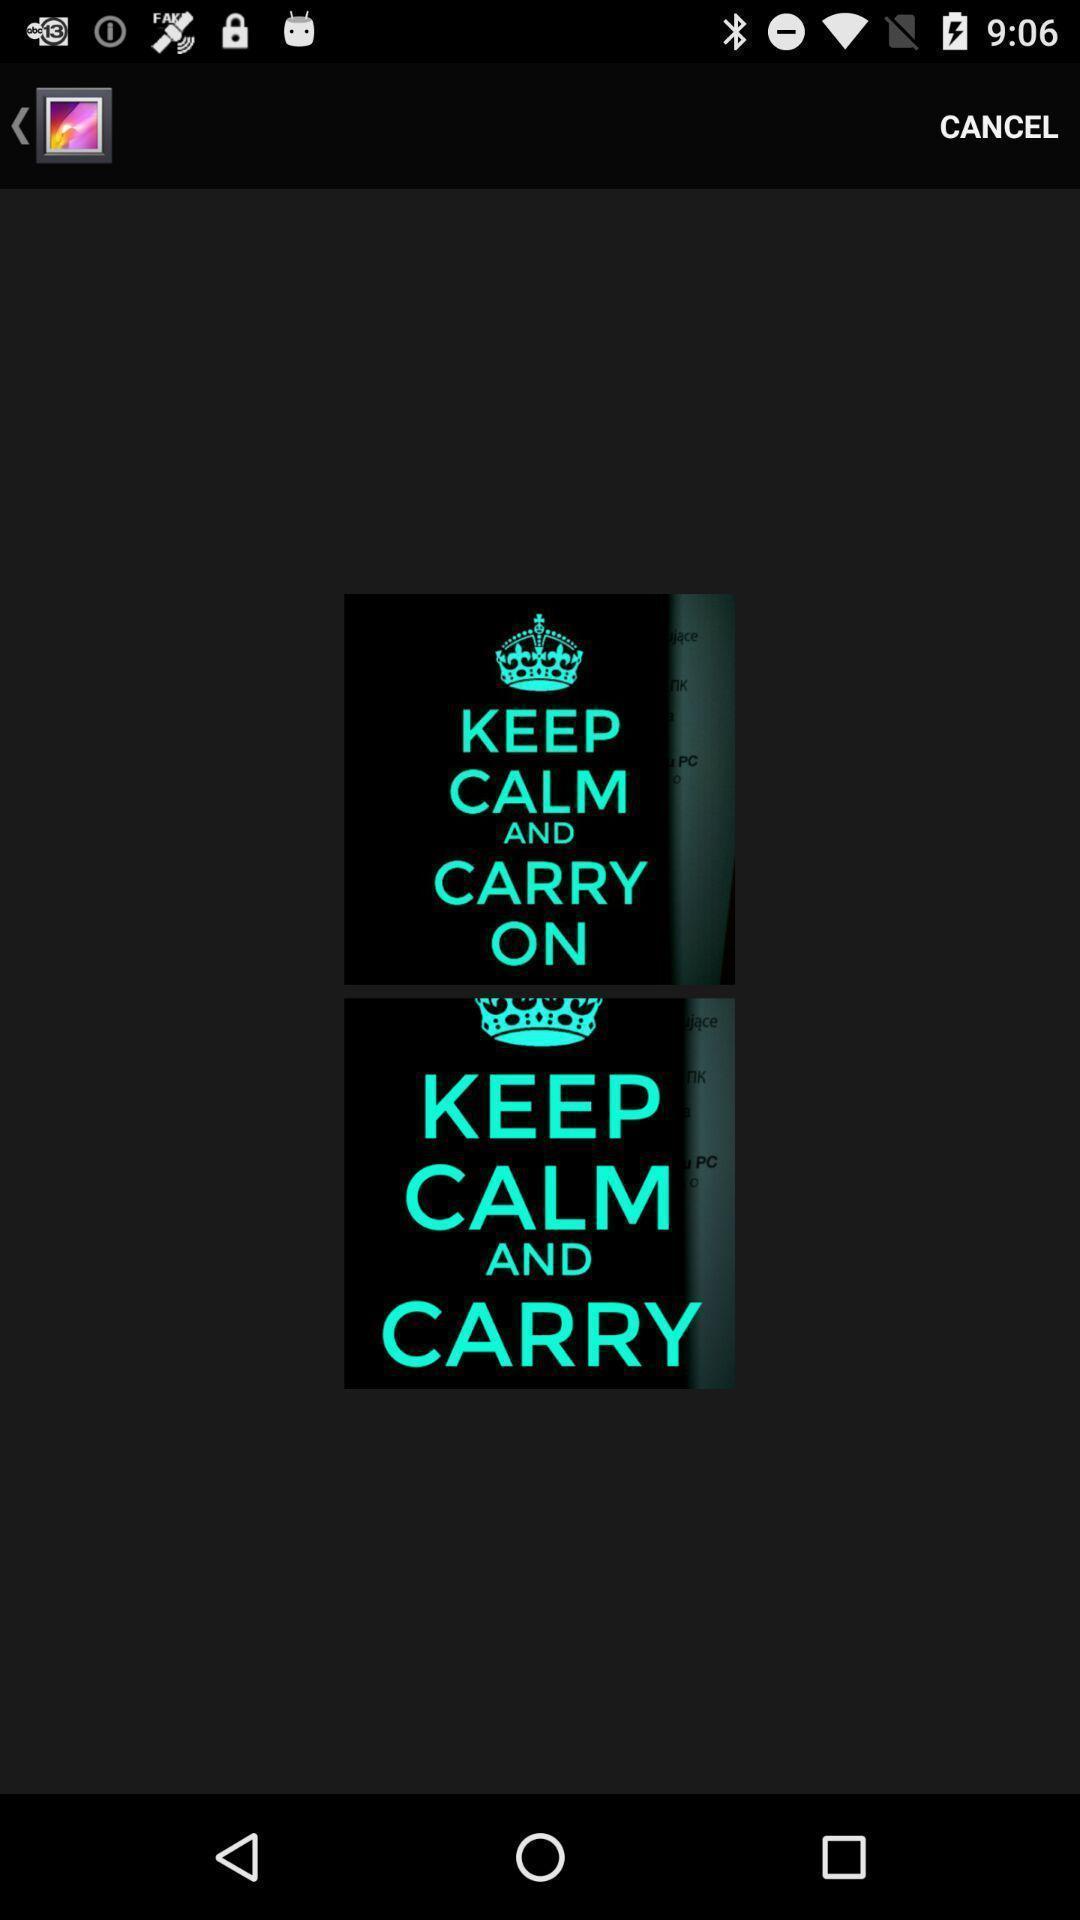Summarize the information in this screenshot. Page displaying various images in gallery application. 